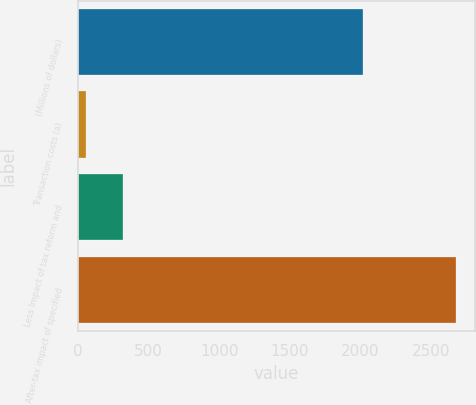Convert chart to OTSL. <chart><loc_0><loc_0><loc_500><loc_500><bar_chart><fcel>(Millions of dollars)<fcel>Transaction costs (a)<fcel>Less Impact of tax reform and<fcel>After-tax impact of specified<nl><fcel>2018<fcel>56<fcel>317.8<fcel>2674<nl></chart> 